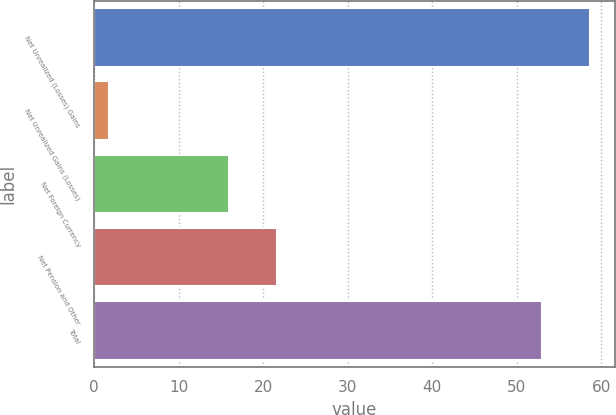<chart> <loc_0><loc_0><loc_500><loc_500><bar_chart><fcel>Net Unrealized (Losses) Gains<fcel>Net Unrealized Gains (Losses)<fcel>Net Foreign Currency<fcel>Net Pension and Other<fcel>Total<nl><fcel>58.69<fcel>1.7<fcel>15.9<fcel>21.59<fcel>53<nl></chart> 